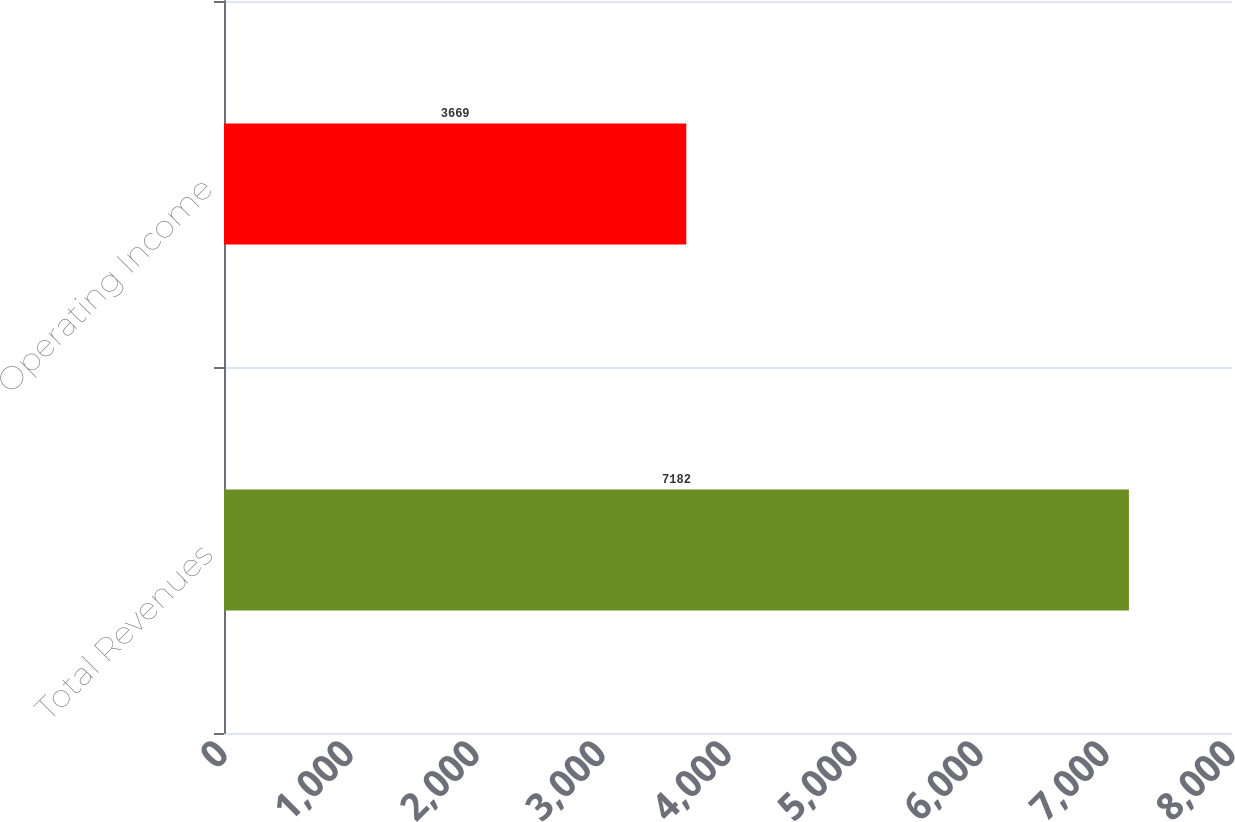Convert chart to OTSL. <chart><loc_0><loc_0><loc_500><loc_500><bar_chart><fcel>Total Revenues<fcel>Operating Income<nl><fcel>7182<fcel>3669<nl></chart> 